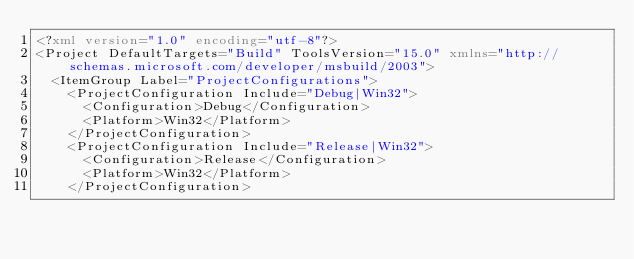<code> <loc_0><loc_0><loc_500><loc_500><_XML_><?xml version="1.0" encoding="utf-8"?>
<Project DefaultTargets="Build" ToolsVersion="15.0" xmlns="http://schemas.microsoft.com/developer/msbuild/2003">
  <ItemGroup Label="ProjectConfigurations">
    <ProjectConfiguration Include="Debug|Win32">
      <Configuration>Debug</Configuration>
      <Platform>Win32</Platform>
    </ProjectConfiguration>
    <ProjectConfiguration Include="Release|Win32">
      <Configuration>Release</Configuration>
      <Platform>Win32</Platform>
    </ProjectConfiguration></code> 